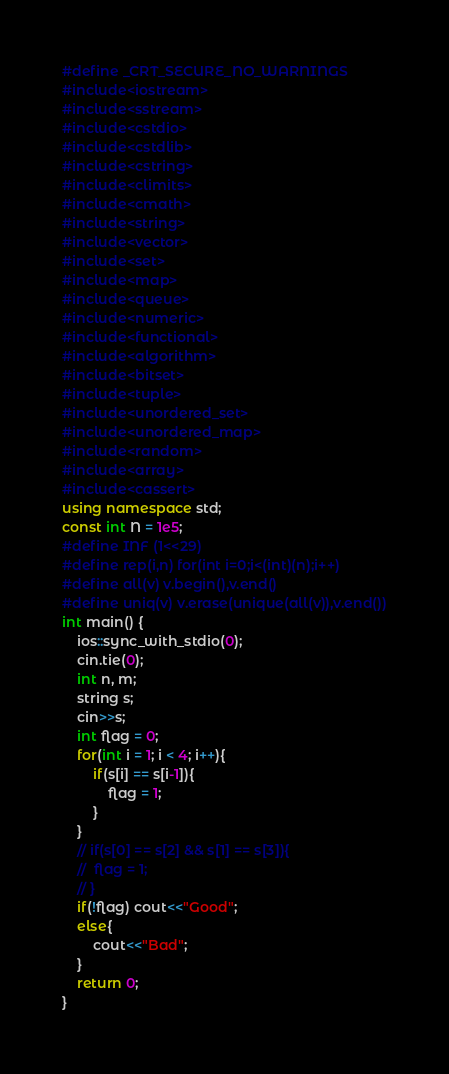<code> <loc_0><loc_0><loc_500><loc_500><_C++_>#define _CRT_SECURE_NO_WARNINGS
#include<iostream>
#include<sstream>
#include<cstdio>
#include<cstdlib>
#include<cstring>
#include<climits>
#include<cmath>
#include<string>
#include<vector>
#include<set>
#include<map>
#include<queue>
#include<numeric>
#include<functional>
#include<algorithm>
#include<bitset>
#include<tuple>
#include<unordered_set>
#include<unordered_map>
#include<random>
#include<array>
#include<cassert>
using namespace std;
const int N = 1e5;
#define INF (1<<29)
#define rep(i,n) for(int i=0;i<(int)(n);i++)
#define all(v) v.begin(),v.end()
#define uniq(v) v.erase(unique(all(v)),v.end())
int main() {
	ios::sync_with_stdio(0);
	cin.tie(0);
	int n, m;
	string s;
	cin>>s;
	int flag = 0;
	for(int i = 1; i < 4; i++){
		if(s[i] == s[i-1]){
			flag = 1;
		}
	}
	// if(s[0] == s[2] && s[1] == s[3]){
	// 	flag = 1;
	// }
	if(!flag) cout<<"Good";
	else{
		cout<<"Bad";
	}
	return 0;
}
</code> 